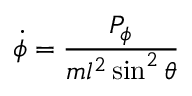<formula> <loc_0><loc_0><loc_500><loc_500>{ \dot { \phi } } = { \frac { P _ { \phi } } { m l ^ { 2 } \sin ^ { 2 } \theta } }</formula> 